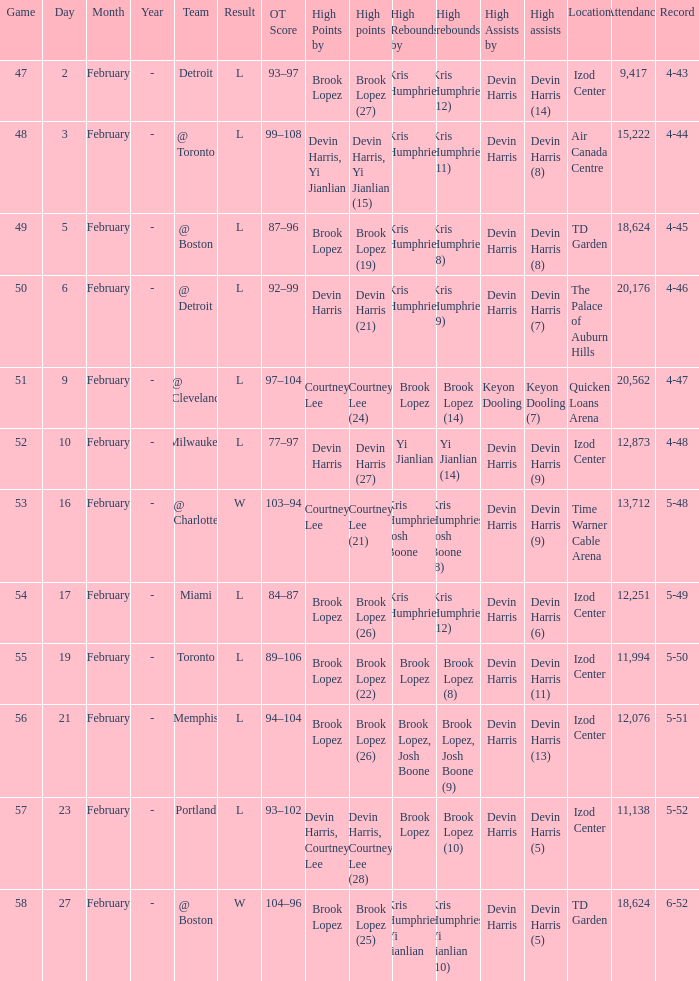What's the highest game number for a game in which Kris Humphries (8) did the high rebounds? 49.0. 